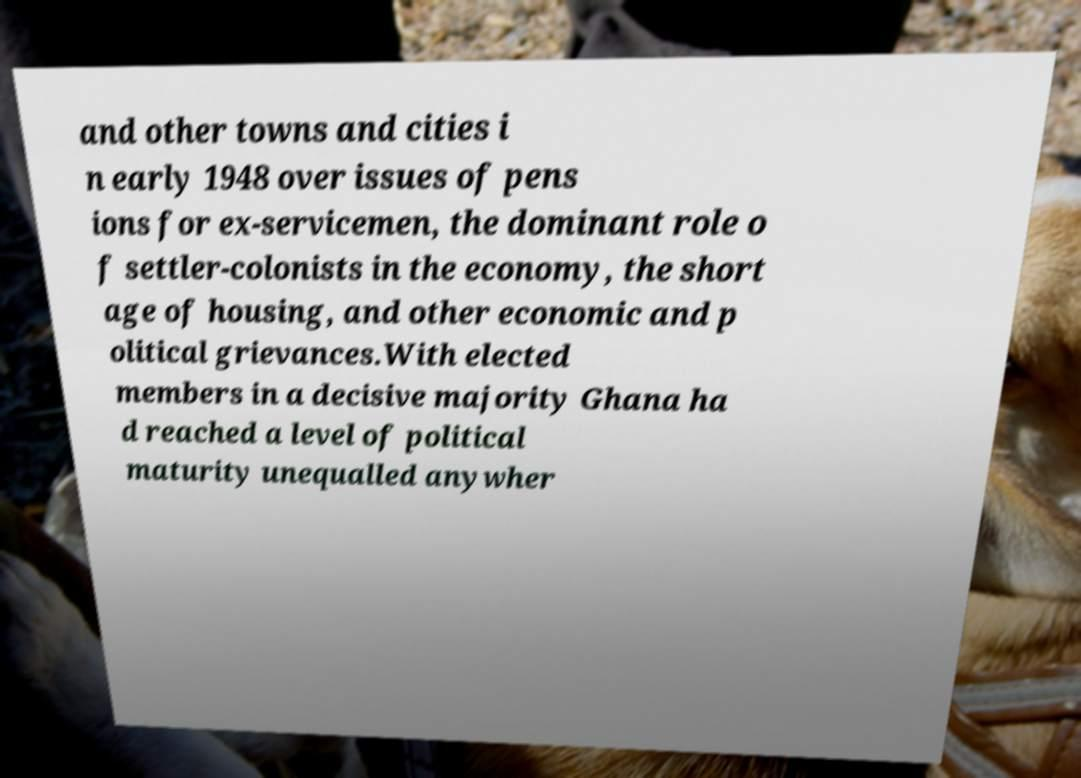Can you read and provide the text displayed in the image?This photo seems to have some interesting text. Can you extract and type it out for me? and other towns and cities i n early 1948 over issues of pens ions for ex-servicemen, the dominant role o f settler-colonists in the economy, the short age of housing, and other economic and p olitical grievances.With elected members in a decisive majority Ghana ha d reached a level of political maturity unequalled anywher 